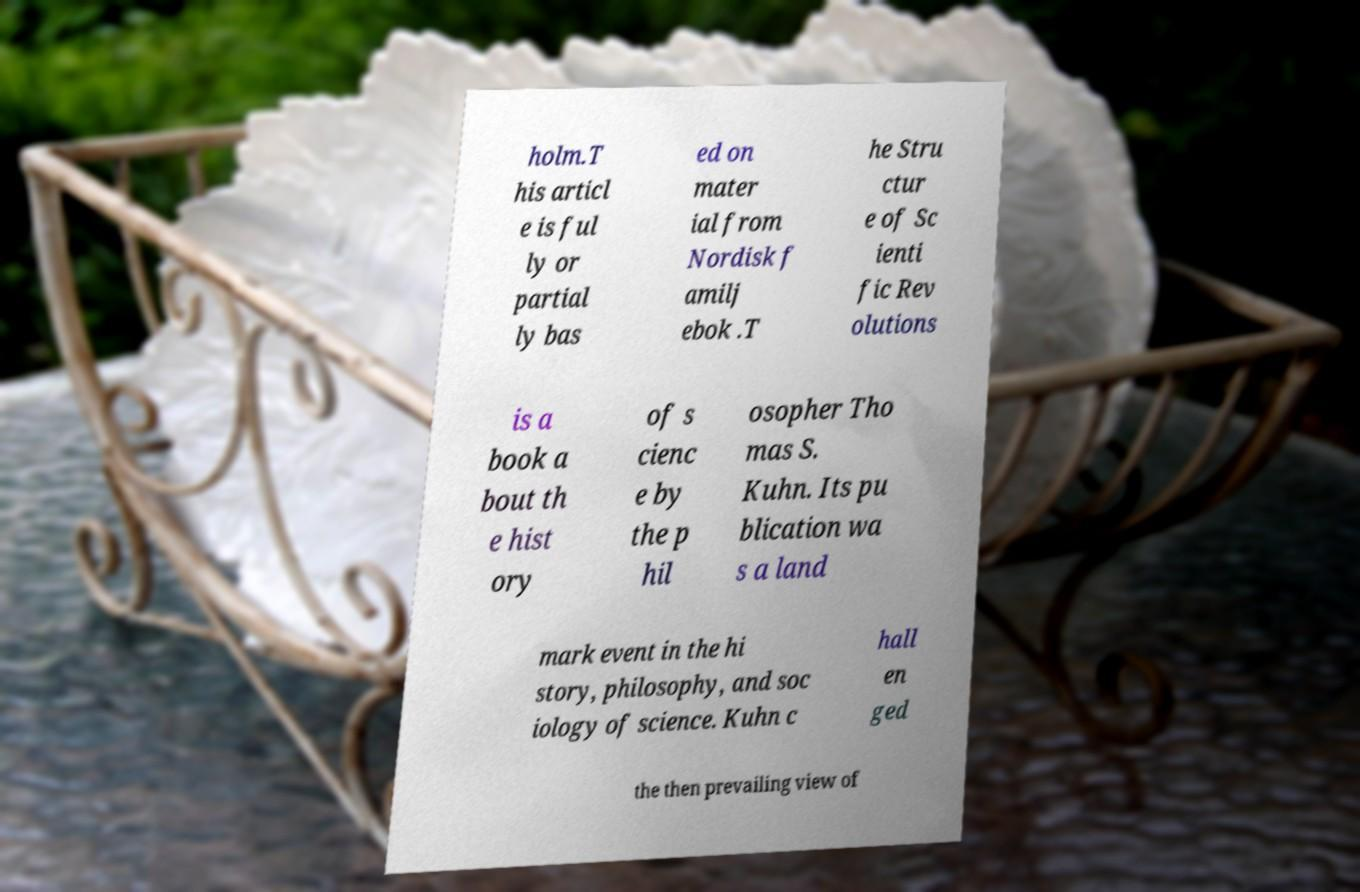Could you assist in decoding the text presented in this image and type it out clearly? holm.T his articl e is ful ly or partial ly bas ed on mater ial from Nordisk f amilj ebok .T he Stru ctur e of Sc ienti fic Rev olutions is a book a bout th e hist ory of s cienc e by the p hil osopher Tho mas S. Kuhn. Its pu blication wa s a land mark event in the hi story, philosophy, and soc iology of science. Kuhn c hall en ged the then prevailing view of 